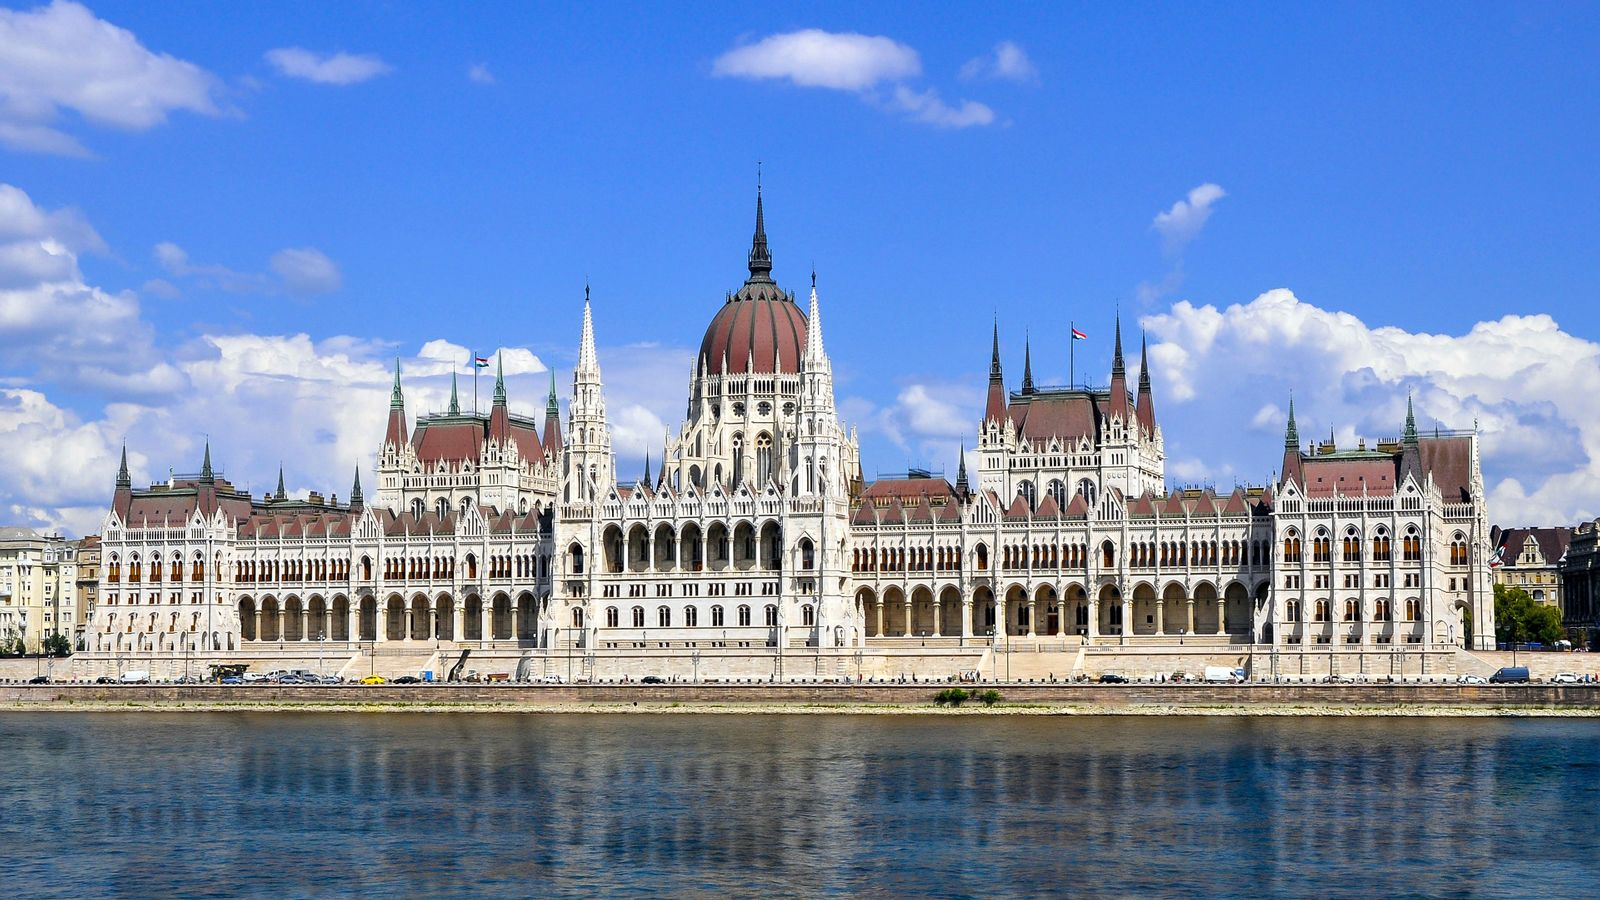If you could step into this image, what would you experience? Stepping into this image would immerse you in the grandeur of Budapest, with the Hungarian Parliament Building standing as an awe-inspiring masterpiece before you. As you stand on the banks of the Danube River, the tranquility of the water reflects the majestic structures along its shores. The ornate details of the Parliament Building come to life, each spire and statue telling a story of Hungary's rich history. The clear blue sky and gentle clouds enhance the serene atmosphere, making it a perfect day to explore the architectural marvel up close. The grandiosity of the building, coupled with the peaceful surroundings, evokes a sense of wonder and admiration for the incredible craftsmanship and historical significance. 